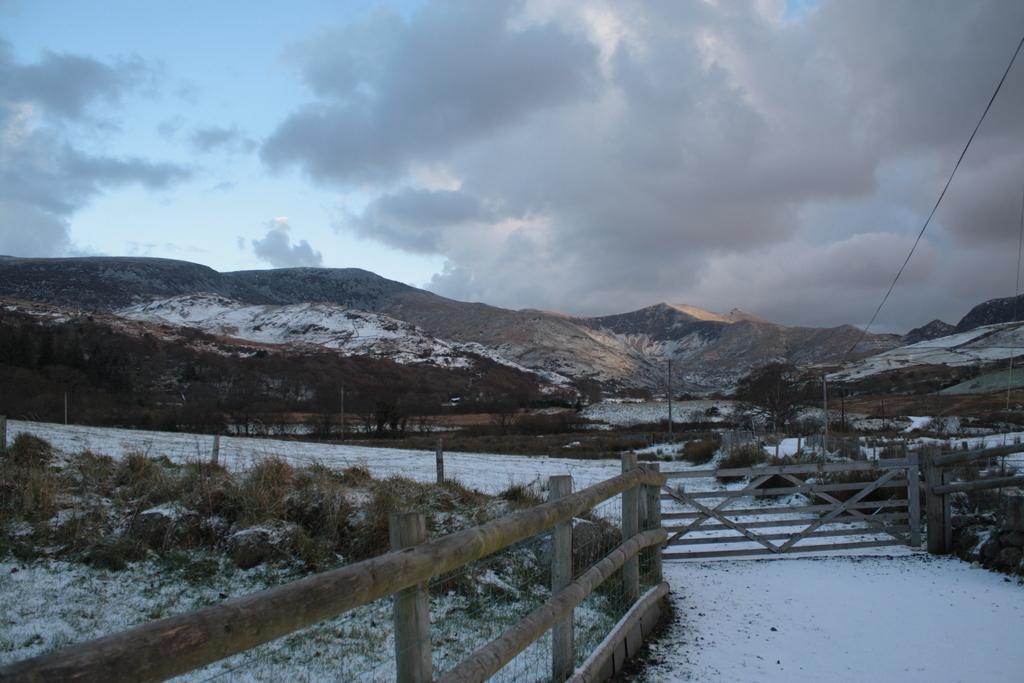Please provide a concise description of this image. In this picture we can see mountains, snow and trees. On the bottom right there is a wooden fencing and gate. On the left we can see stones and grass. On the top we can see sky and clouds. Here we can see some electric poles and wires are connected to it. 